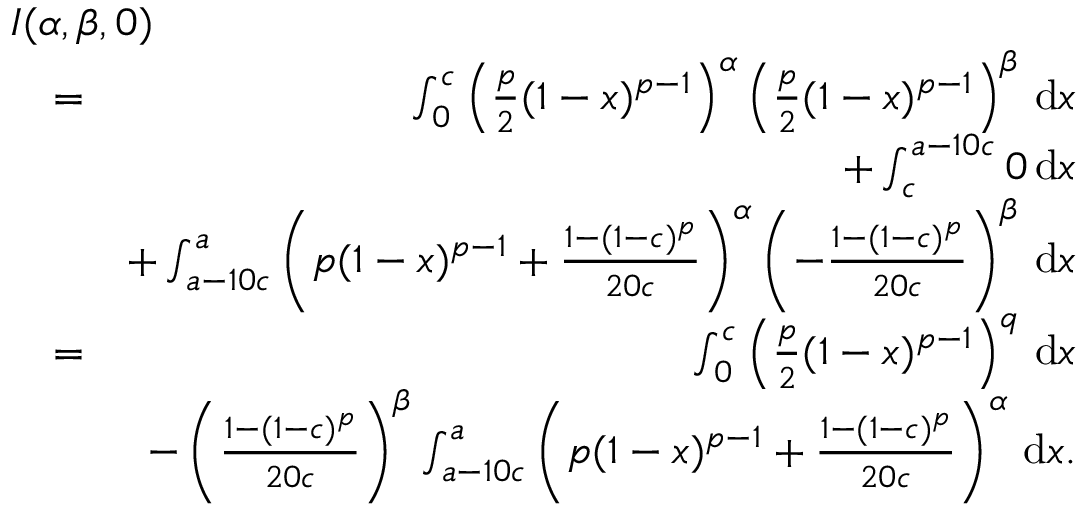Convert formula to latex. <formula><loc_0><loc_0><loc_500><loc_500>\begin{array} { r l r } { { I ( \alpha , \beta , 0 ) } } \\ & { = } & { \int _ { 0 } ^ { c } \left ( \frac { p } { 2 } ( 1 - x ) ^ { p - 1 } \right ) ^ { \alpha } \left ( \frac { p } { 2 } ( 1 - x ) ^ { p - 1 } \right ) ^ { \beta } \, d x } \\ & { + \int _ { c } ^ { a - 1 0 c } 0 \, d x } \\ & { + \int _ { a - 1 0 c } ^ { a } \left ( p ( 1 - x ) ^ { p - 1 } + \frac { 1 - ( 1 - c ) ^ { p } } { 2 0 c } \right ) ^ { \alpha } \left ( - \frac { 1 - ( 1 - c ) ^ { p } } { 2 0 c } \right ) ^ { \beta } \, d x } \\ & { = } & { \int _ { 0 } ^ { c } \left ( \frac { p } { 2 } ( 1 - x ) ^ { p - 1 } \right ) ^ { q } \, d x } \\ & { - \left ( \frac { 1 - ( 1 - c ) ^ { p } } { 2 0 c } \right ) ^ { \beta } \int _ { a - 1 0 c } ^ { a } \left ( p ( 1 - x ) ^ { p - 1 } + \frac { 1 - ( 1 - c ) ^ { p } } { 2 0 c } \right ) ^ { \alpha } \, d x . } \end{array}</formula> 